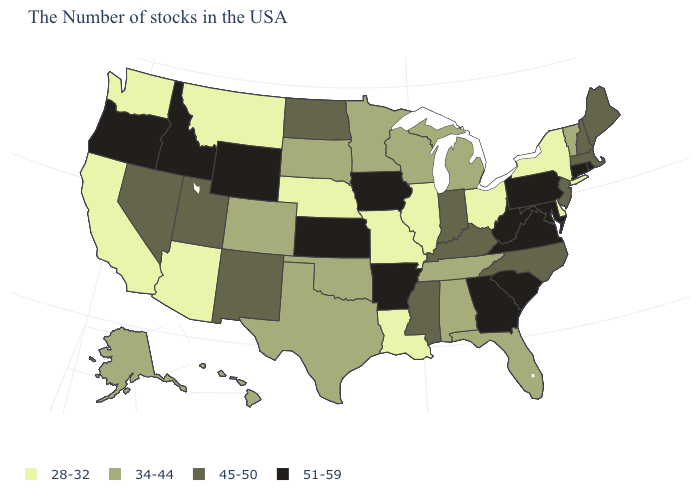Name the states that have a value in the range 45-50?
Concise answer only. Maine, Massachusetts, New Hampshire, New Jersey, North Carolina, Kentucky, Indiana, Mississippi, North Dakota, New Mexico, Utah, Nevada. Among the states that border North Carolina , which have the lowest value?
Short answer required. Tennessee. Name the states that have a value in the range 34-44?
Concise answer only. Vermont, Florida, Michigan, Alabama, Tennessee, Wisconsin, Minnesota, Oklahoma, Texas, South Dakota, Colorado, Alaska, Hawaii. What is the value of Wyoming?
Be succinct. 51-59. What is the value of Illinois?
Short answer required. 28-32. What is the value of South Dakota?
Keep it brief. 34-44. Name the states that have a value in the range 34-44?
Give a very brief answer. Vermont, Florida, Michigan, Alabama, Tennessee, Wisconsin, Minnesota, Oklahoma, Texas, South Dakota, Colorado, Alaska, Hawaii. What is the highest value in the Northeast ?
Keep it brief. 51-59. Does Idaho have the highest value in the USA?
Concise answer only. Yes. What is the value of Ohio?
Write a very short answer. 28-32. What is the lowest value in the USA?
Quick response, please. 28-32. Name the states that have a value in the range 34-44?
Answer briefly. Vermont, Florida, Michigan, Alabama, Tennessee, Wisconsin, Minnesota, Oklahoma, Texas, South Dakota, Colorado, Alaska, Hawaii. Does Kansas have the highest value in the USA?
Quick response, please. Yes. Name the states that have a value in the range 34-44?
Short answer required. Vermont, Florida, Michigan, Alabama, Tennessee, Wisconsin, Minnesota, Oklahoma, Texas, South Dakota, Colorado, Alaska, Hawaii. Name the states that have a value in the range 28-32?
Quick response, please. New York, Delaware, Ohio, Illinois, Louisiana, Missouri, Nebraska, Montana, Arizona, California, Washington. 